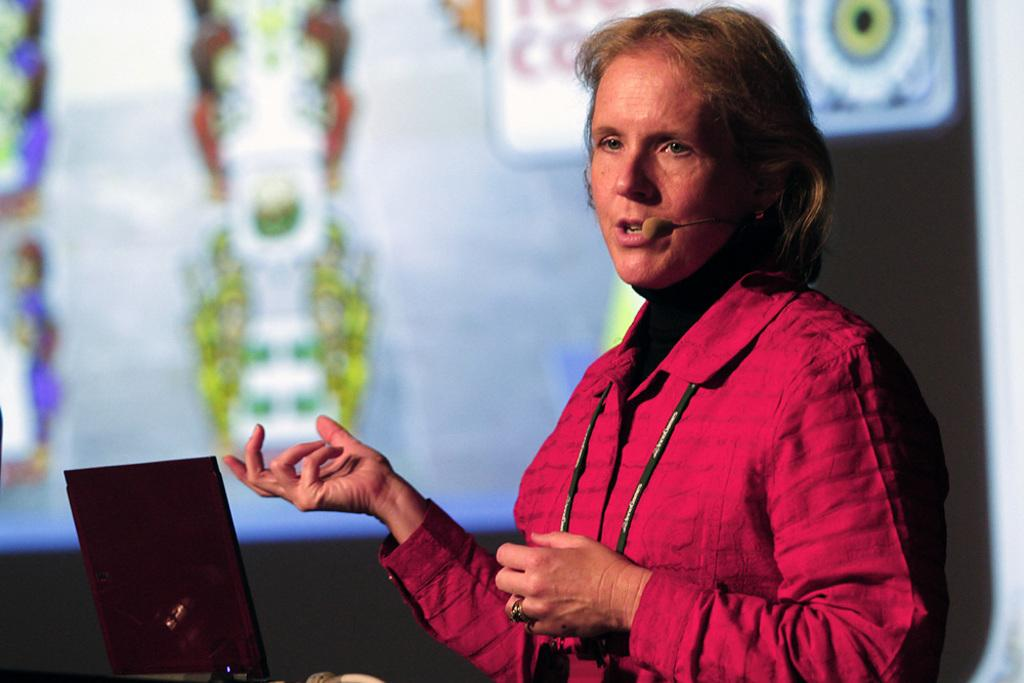Who is the main subject in the image? There is a woman in the image. What is the woman doing in the image? The woman is talking on a microphone. What device is in front of the woman? There is a laptop in front of the woman. What can be seen in the background of the image? There is a screen visible in the background. What type of bait is the woman using to attract the audience's attention in the image? There is no bait present in the image; the woman is using a microphone to communicate. What color is the button on the woman's shirt in the image? There is no button mentioned or visible on the woman's shirt in the image. 